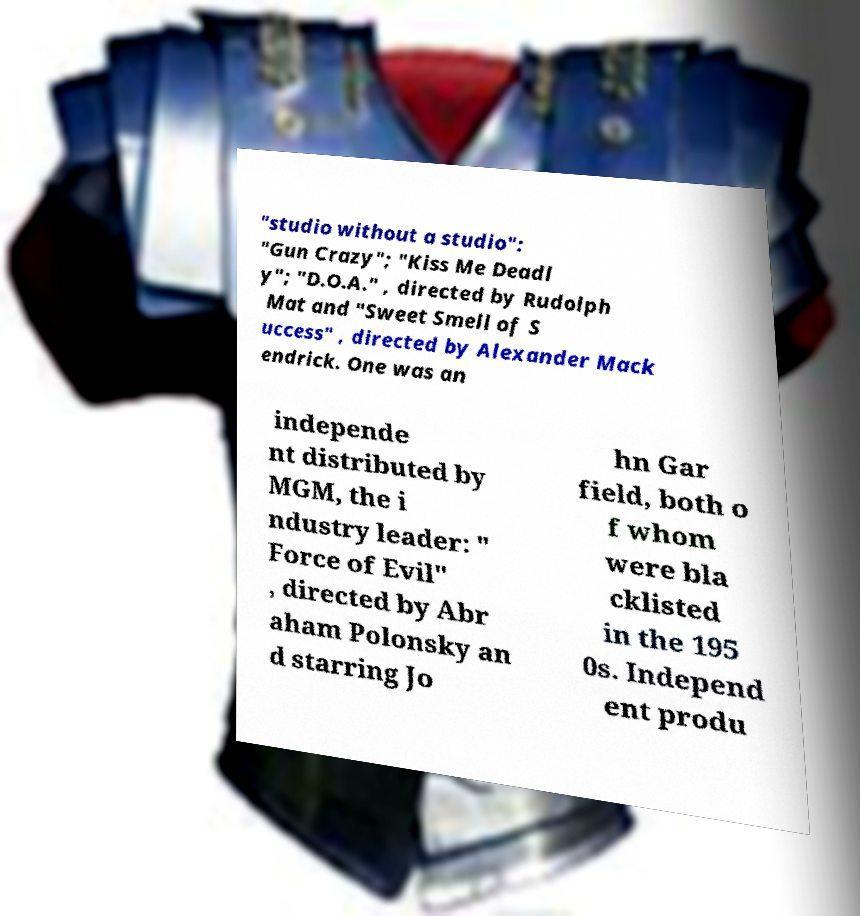I need the written content from this picture converted into text. Can you do that? "studio without a studio": "Gun Crazy"; "Kiss Me Deadl y"; "D.O.A." , directed by Rudolph Mat and "Sweet Smell of S uccess" , directed by Alexander Mack endrick. One was an independe nt distributed by MGM, the i ndustry leader: " Force of Evil" , directed by Abr aham Polonsky an d starring Jo hn Gar field, both o f whom were bla cklisted in the 195 0s. Independ ent produ 